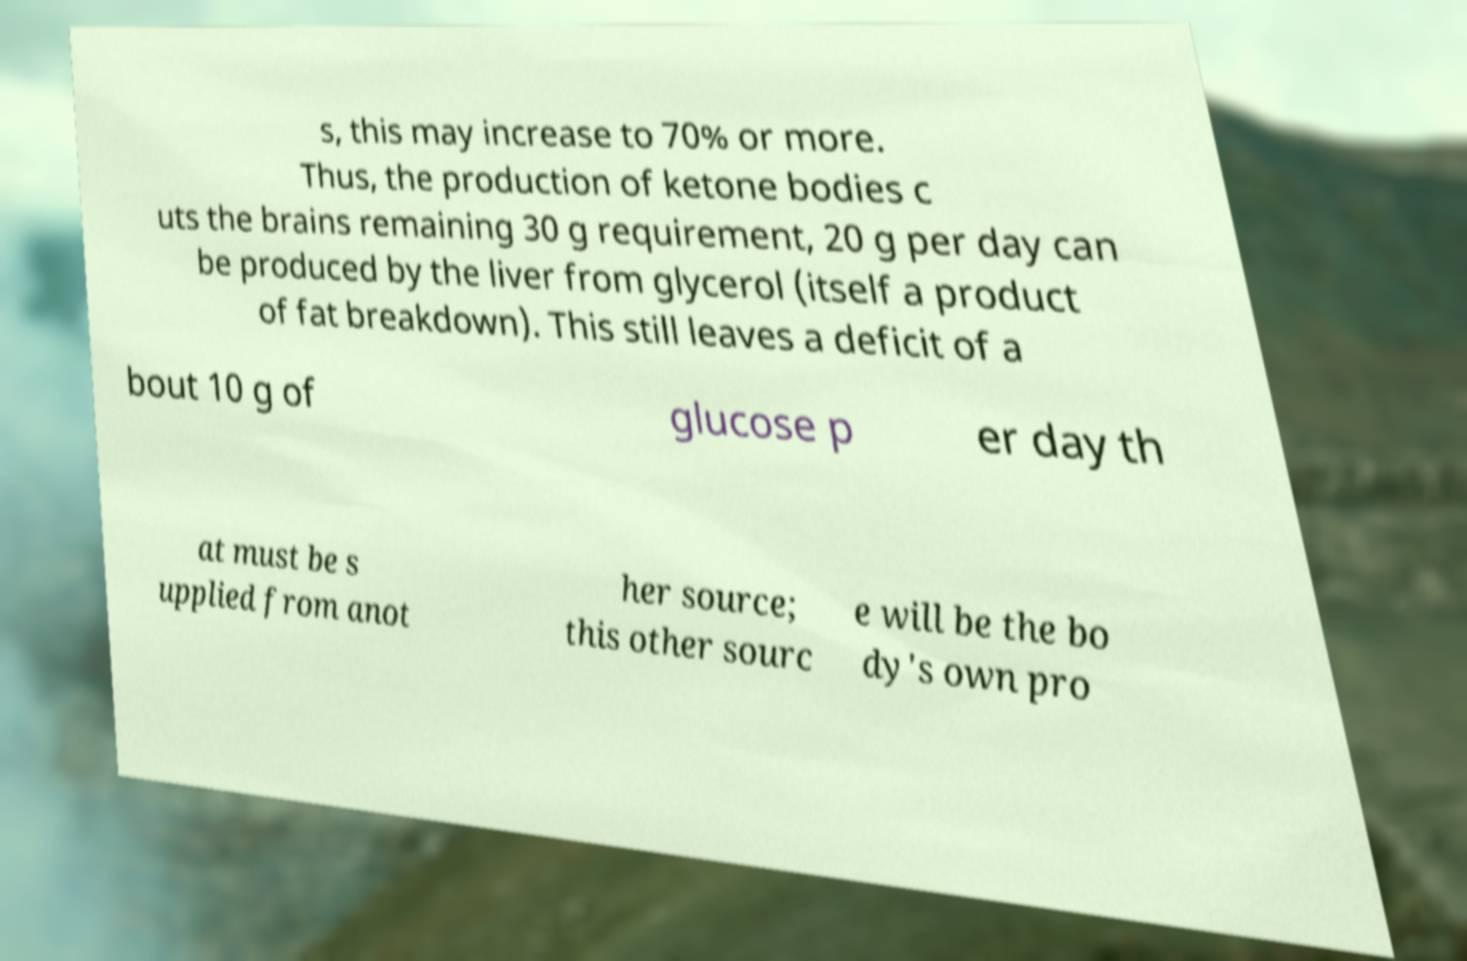Could you assist in decoding the text presented in this image and type it out clearly? s, this may increase to 70% or more. Thus, the production of ketone bodies c uts the brains remaining 30 g requirement, 20 g per day can be produced by the liver from glycerol (itself a product of fat breakdown). This still leaves a deficit of a bout 10 g of glucose p er day th at must be s upplied from anot her source; this other sourc e will be the bo dy's own pro 